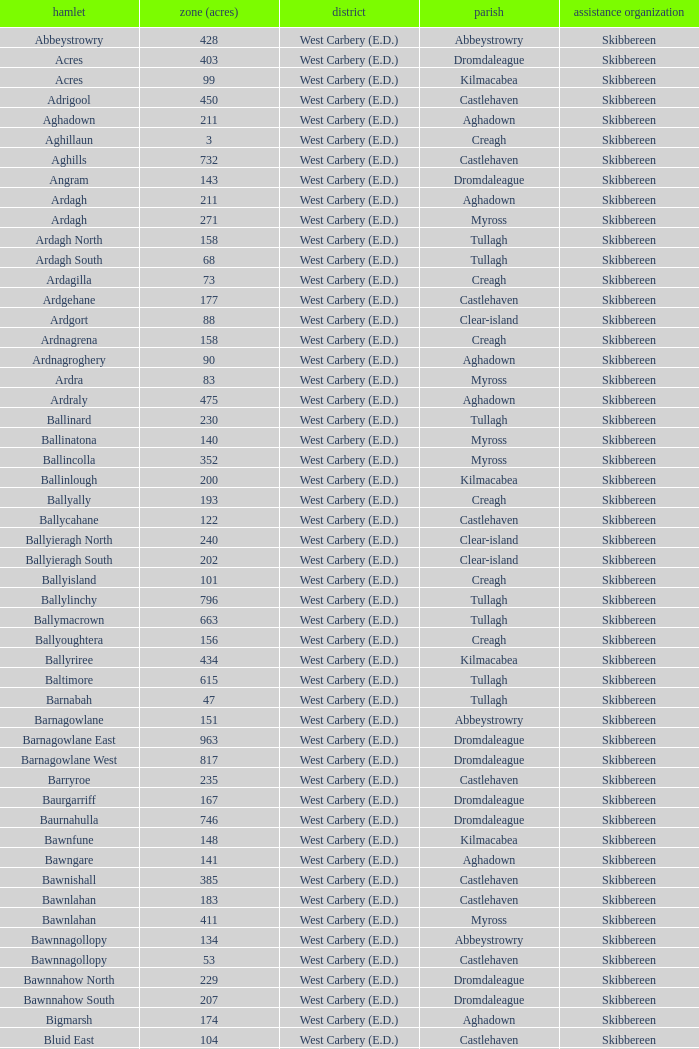What are the Poor Law Unions when the area (in acres) is 142? Skibbereen. 